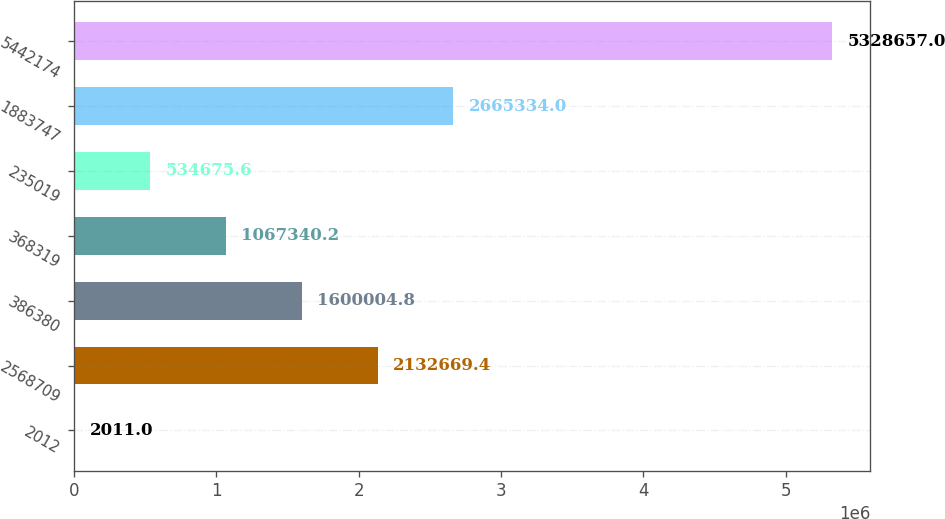<chart> <loc_0><loc_0><loc_500><loc_500><bar_chart><fcel>2012<fcel>2568709<fcel>386380<fcel>368319<fcel>235019<fcel>1883747<fcel>5442174<nl><fcel>2011<fcel>2.13267e+06<fcel>1.6e+06<fcel>1.06734e+06<fcel>534676<fcel>2.66533e+06<fcel>5.32866e+06<nl></chart> 